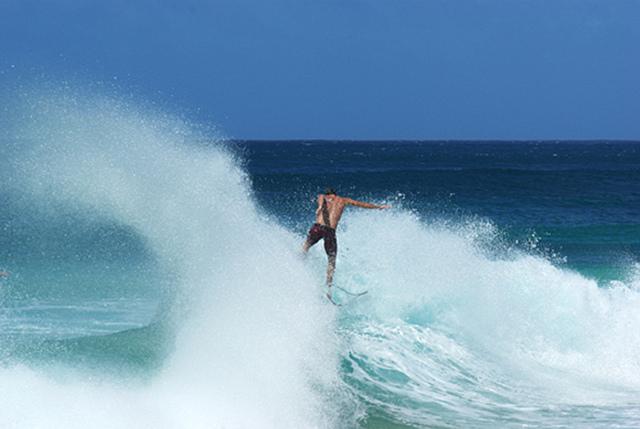Is someone likely to swallow some seawater?
Keep it brief. Yes. Is the man wearing shorts?
Keep it brief. Yes. Is the water cold?
Be succinct. Yes. Are both of the man's arms in the picture facing straight out?
Concise answer only. No. Is it a sunny or clouding day?
Write a very short answer. Sunny. Is the man still in contact with his surfboard?
Short answer required. Yes. 